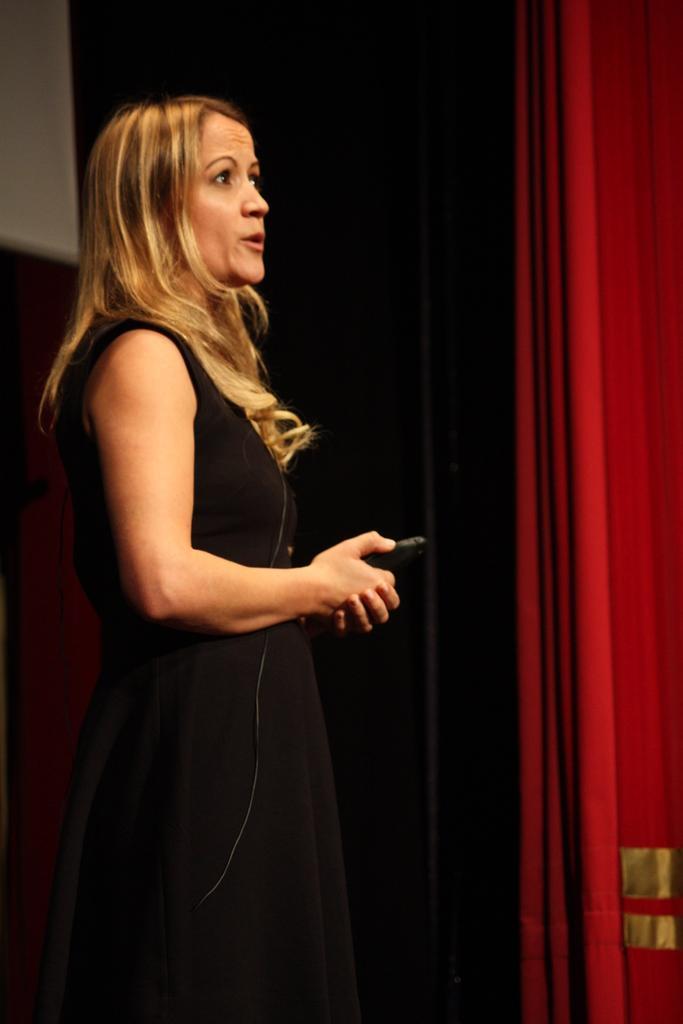Could you give a brief overview of what you see in this image? In this image there is a woman wearing a black dress and holding a mobile phone. In the background there is a red color curtain. 